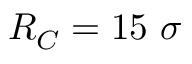Convert formula to latex. <formula><loc_0><loc_0><loc_500><loc_500>R _ { C } = 1 5 \sigma</formula> 